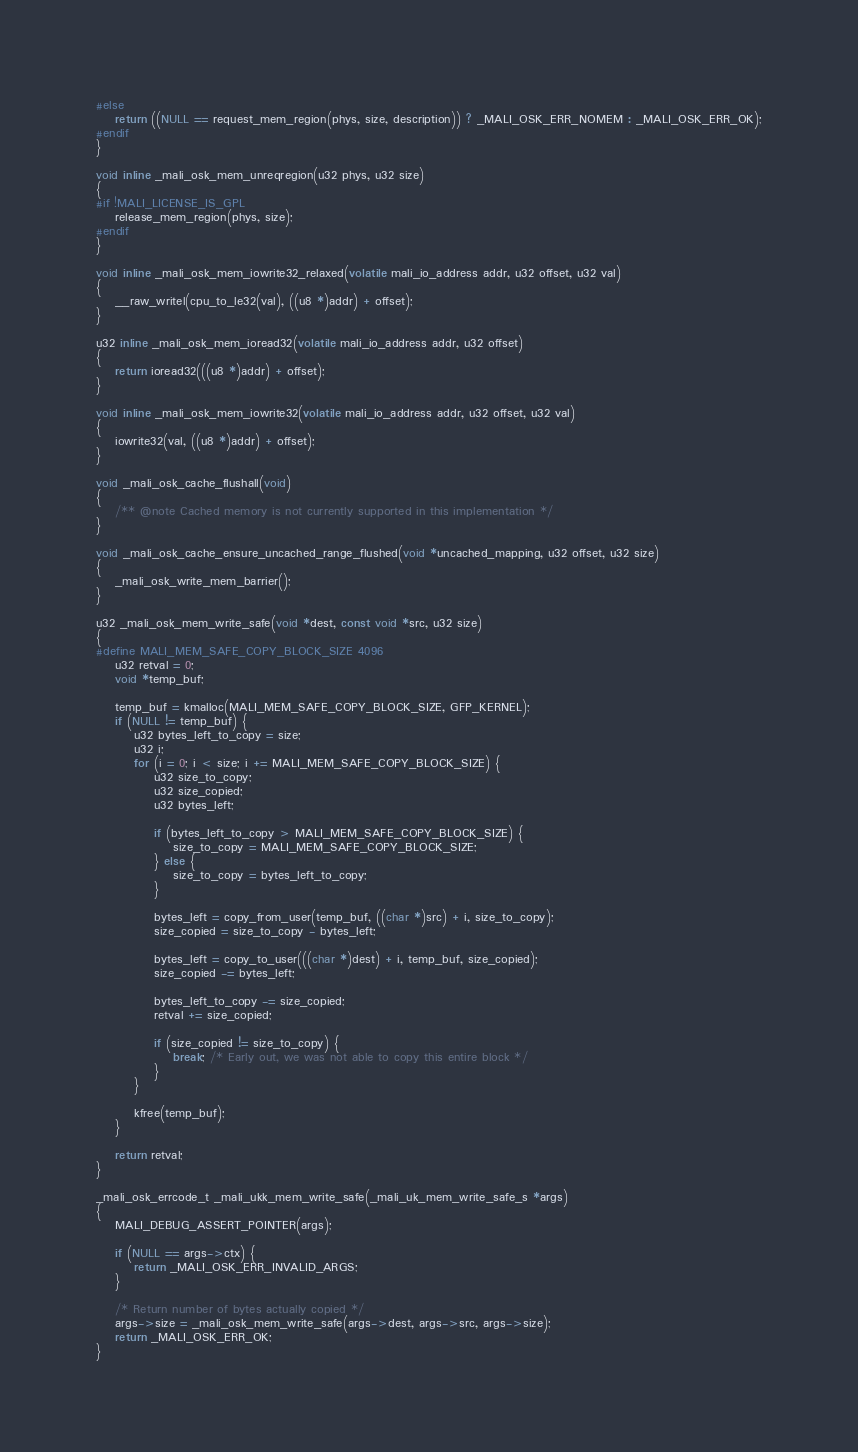Convert code to text. <code><loc_0><loc_0><loc_500><loc_500><_C_>#else
	return ((NULL == request_mem_region(phys, size, description)) ? _MALI_OSK_ERR_NOMEM : _MALI_OSK_ERR_OK);
#endif
}

void inline _mali_osk_mem_unreqregion(u32 phys, u32 size)
{
#if !MALI_LICENSE_IS_GPL
	release_mem_region(phys, size);
#endif
}

void inline _mali_osk_mem_iowrite32_relaxed(volatile mali_io_address addr, u32 offset, u32 val)
{
	__raw_writel(cpu_to_le32(val), ((u8 *)addr) + offset);
}

u32 inline _mali_osk_mem_ioread32(volatile mali_io_address addr, u32 offset)
{
	return ioread32(((u8 *)addr) + offset);
}

void inline _mali_osk_mem_iowrite32(volatile mali_io_address addr, u32 offset, u32 val)
{
	iowrite32(val, ((u8 *)addr) + offset);
}

void _mali_osk_cache_flushall(void)
{
	/** @note Cached memory is not currently supported in this implementation */
}

void _mali_osk_cache_ensure_uncached_range_flushed(void *uncached_mapping, u32 offset, u32 size)
{
	_mali_osk_write_mem_barrier();
}

u32 _mali_osk_mem_write_safe(void *dest, const void *src, u32 size)
{
#define MALI_MEM_SAFE_COPY_BLOCK_SIZE 4096
	u32 retval = 0;
	void *temp_buf;

	temp_buf = kmalloc(MALI_MEM_SAFE_COPY_BLOCK_SIZE, GFP_KERNEL);
	if (NULL != temp_buf) {
		u32 bytes_left_to_copy = size;
		u32 i;
		for (i = 0; i < size; i += MALI_MEM_SAFE_COPY_BLOCK_SIZE) {
			u32 size_to_copy;
			u32 size_copied;
			u32 bytes_left;

			if (bytes_left_to_copy > MALI_MEM_SAFE_COPY_BLOCK_SIZE) {
				size_to_copy = MALI_MEM_SAFE_COPY_BLOCK_SIZE;
			} else {
				size_to_copy = bytes_left_to_copy;
			}

			bytes_left = copy_from_user(temp_buf, ((char *)src) + i, size_to_copy);
			size_copied = size_to_copy - bytes_left;

			bytes_left = copy_to_user(((char *)dest) + i, temp_buf, size_copied);
			size_copied -= bytes_left;

			bytes_left_to_copy -= size_copied;
			retval += size_copied;

			if (size_copied != size_to_copy) {
				break; /* Early out, we was not able to copy this entire block */
			}
		}

		kfree(temp_buf);
	}

	return retval;
}

_mali_osk_errcode_t _mali_ukk_mem_write_safe(_mali_uk_mem_write_safe_s *args)
{
	MALI_DEBUG_ASSERT_POINTER(args);

	if (NULL == args->ctx) {
		return _MALI_OSK_ERR_INVALID_ARGS;
	}

	/* Return number of bytes actually copied */
	args->size = _mali_osk_mem_write_safe(args->dest, args->src, args->size);
	return _MALI_OSK_ERR_OK;
}
</code> 